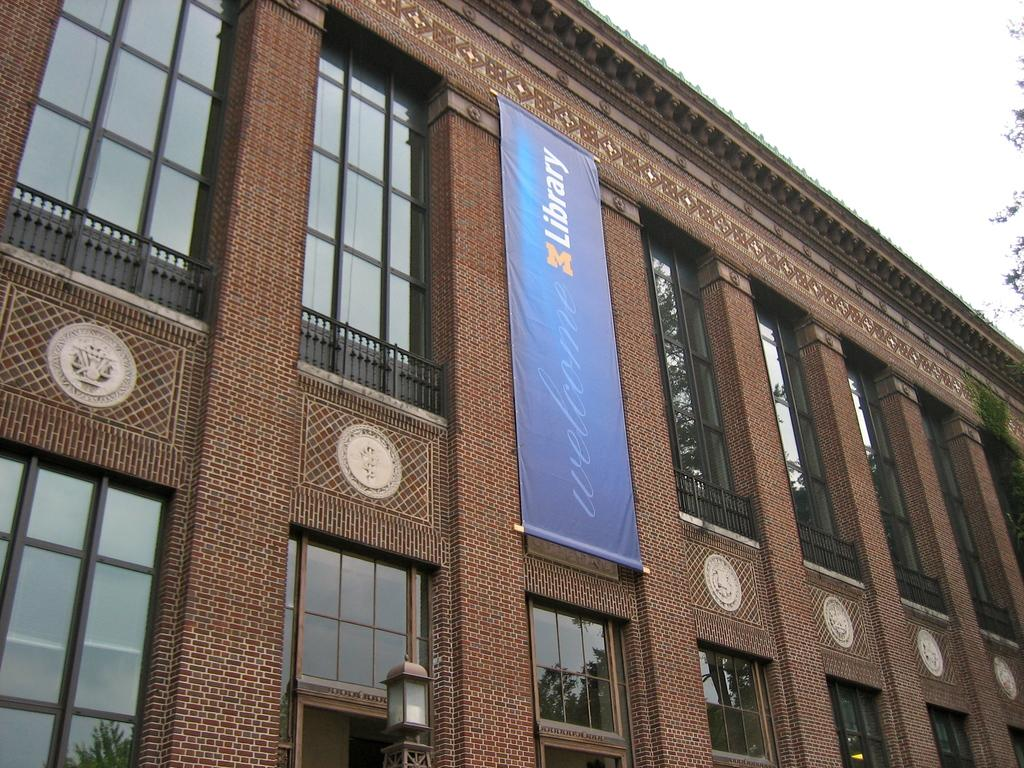<image>
Relay a brief, clear account of the picture shown. A blue banner reading M Library is unfurled against a building. 